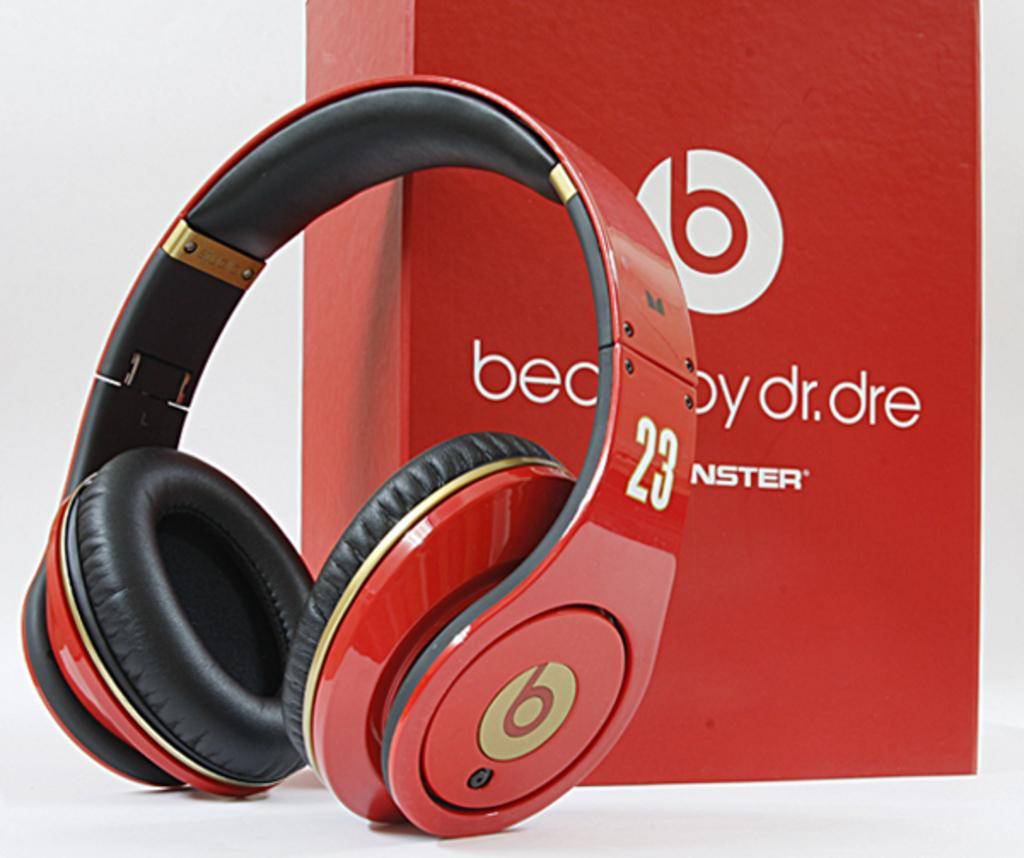What type of headset is visible in the image? There is a wireless headset in the image. Where is the wireless headset located in relation to other objects? The wireless headset is beside a red box. What type of weather is depicted in the image? There is no weather depicted in the image, as it is an indoor scene with a wireless headset and a red box. 